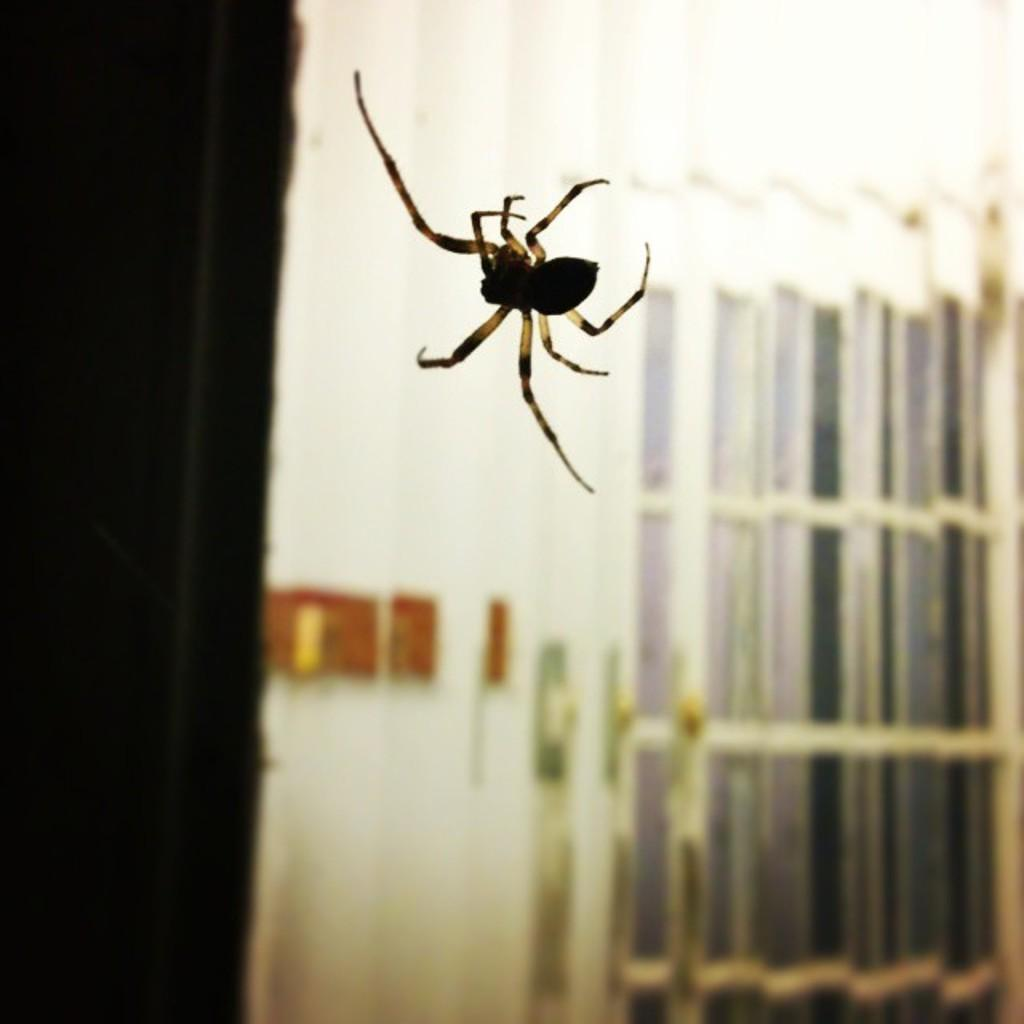What type of animal can be seen in the image? There is a spider in the image. Where is the owner of the spider walking in the image? There is no owner of the spider present in the image, nor is there any indication of a sidewalk or walking. 